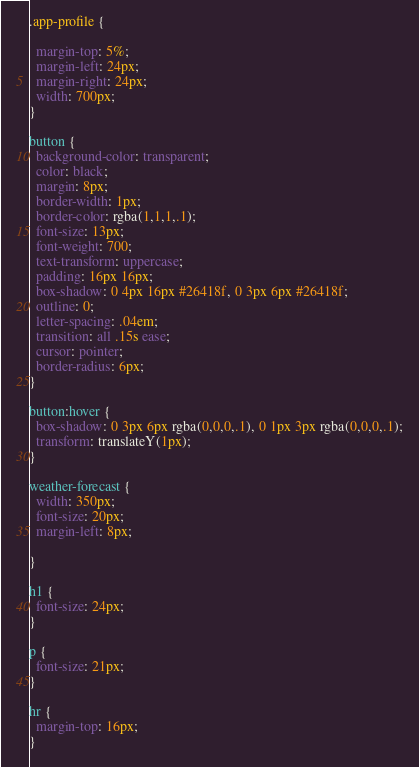Convert code to text. <code><loc_0><loc_0><loc_500><loc_500><_CSS_>.app-profile {

  margin-top: 5%;
  margin-left: 24px;
  margin-right: 24px;
  width: 700px;
}

button {
  background-color: transparent;
  color: black;
  margin: 8px;
  border-width: 1px;
  border-color: rgba(1,1,1,.1);
  font-size: 13px;
  font-weight: 700;
  text-transform: uppercase;
  padding: 16px 16px;
  box-shadow: 0 4px 16px #26418f, 0 3px 6px #26418f;
  outline: 0;
  letter-spacing: .04em;
  transition: all .15s ease;
  cursor: pointer;
  border-radius: 6px;
}

button:hover {
  box-shadow: 0 3px 6px rgba(0,0,0,.1), 0 1px 3px rgba(0,0,0,.1);
  transform: translateY(1px);
}

weather-forecast {
  width: 350px;
  font-size: 20px;
  margin-left: 8px;

}

h1 {
  font-size: 24px;
}

p {
  font-size: 21px;
}

hr {
  margin-top: 16px;
}
</code> 